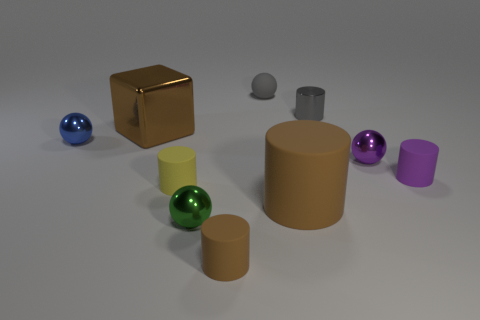What is the material of the big brown cylinder? While the image does not enable me to determine the material with certainty, the big brown cylinder appears to be a matte, non-reflective surface which could suggest a material like plastic or painted metal, commonly used for 3D modeling and rendering. 